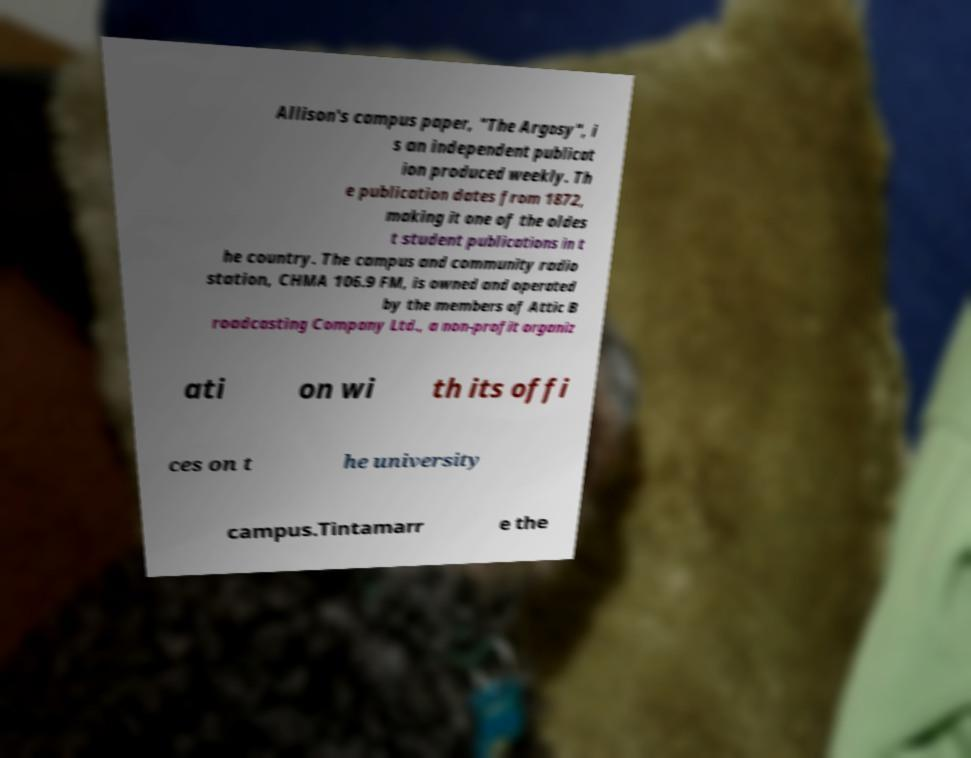Please identify and transcribe the text found in this image. Allison's campus paper, "The Argosy", i s an independent publicat ion produced weekly. Th e publication dates from 1872, making it one of the oldes t student publications in t he country. The campus and community radio station, CHMA 106.9 FM, is owned and operated by the members of Attic B roadcasting Company Ltd., a non-profit organiz ati on wi th its offi ces on t he university campus.Tintamarr e the 